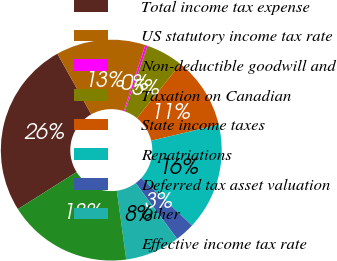<chart> <loc_0><loc_0><loc_500><loc_500><pie_chart><fcel>Total income tax expense<fcel>US statutory income tax rate<fcel>Non-deductible goodwill and<fcel>Taxation on Canadian<fcel>State income taxes<fcel>Repatriations<fcel>Deferred tax asset valuation<fcel>Other<fcel>Effective income tax rate<nl><fcel>25.86%<fcel>13.1%<fcel>0.34%<fcel>5.44%<fcel>10.54%<fcel>15.65%<fcel>2.89%<fcel>7.99%<fcel>18.2%<nl></chart> 